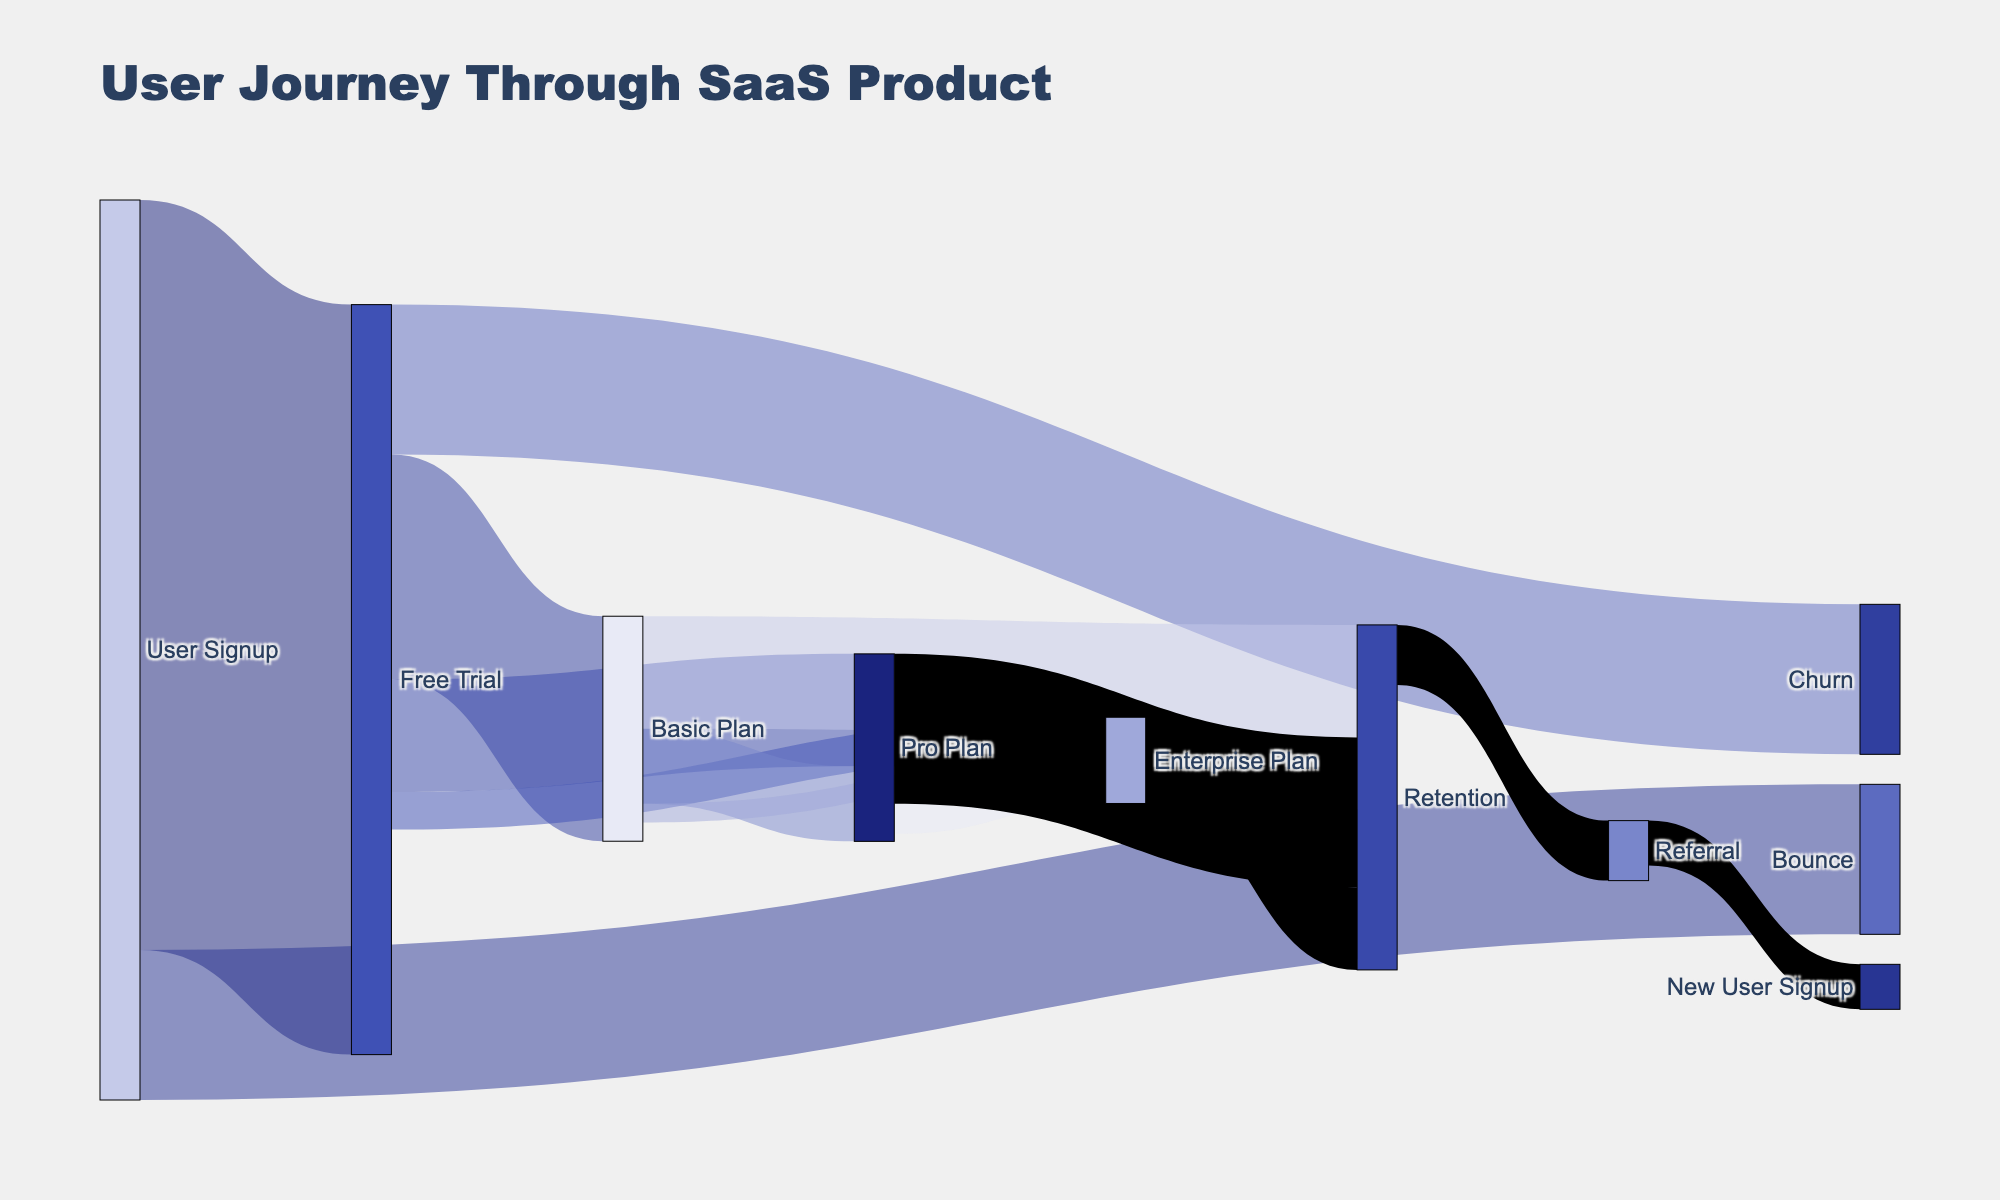What is the title of the Sankey diagram? The title is displayed at the top of the figure and labeled "User Journey Through SaaS Product".
Answer: User Journey Through SaaS Product How many users signed up for the free trial? Find the flow from "User Signup" to "Free Trial" which shows a value of 1000 users.
Answer: 1000 What is the total number of users who did not convert to any subscription plan from the free trial? Look for the "Free Trial" moving to "Churn", which indicates 200 users did not convert.
Answer: 200 Which subscription plan has the highest retention after starting from the 'Free Trial'? Compare the "Retention" values derived from "Basic Plan", "Pro Plan", and "Enterprise Plan", where "Pro Plan" to "Retention" has the highest value (200).
Answer: Pro Plan How many users moved from 'Basic Plan' to 'Enterprise Plan'? Trace the flow from "Basic Plan" to "Enterprise Plan", which records a value of 25 users.
Answer: 25 What's the total number of users in any retention plan at the end? Sum the users retained in "Basic Plan", "Pro Plan", and "Enterprise Plan" to "Retention" (150 + 200 + 110 = 460).
Answer: 460 What percentage of users who started a 'Pro Plan' moved to 'Enterprise Plan'? Calculate the percentage of users from "Pro Plan" to "Enterprise Plan" out of total "Pro Plan" users (40 out of 150 = 40 / 150 * 100 ≈ 26.67%).
Answer: Approximately 26.67% How many users referred new users after retention? Refer to the flow from "Retention" to "Referral", noting 80 users.
Answer: 80 Which initial step had more users, "User Signup" to "Free Trial" or "User Signup" to "Bounce"? Compare the values from "User Signup": 1000 to "Free Trial" and 200 to "Bounce". More users signed up for the "Free Trial" (1000 > 200).
Answer: Free Trial How many new sign-ups result from referrals? Check the value from "Referral" to "New User Signup," which is 60.
Answer: 60 